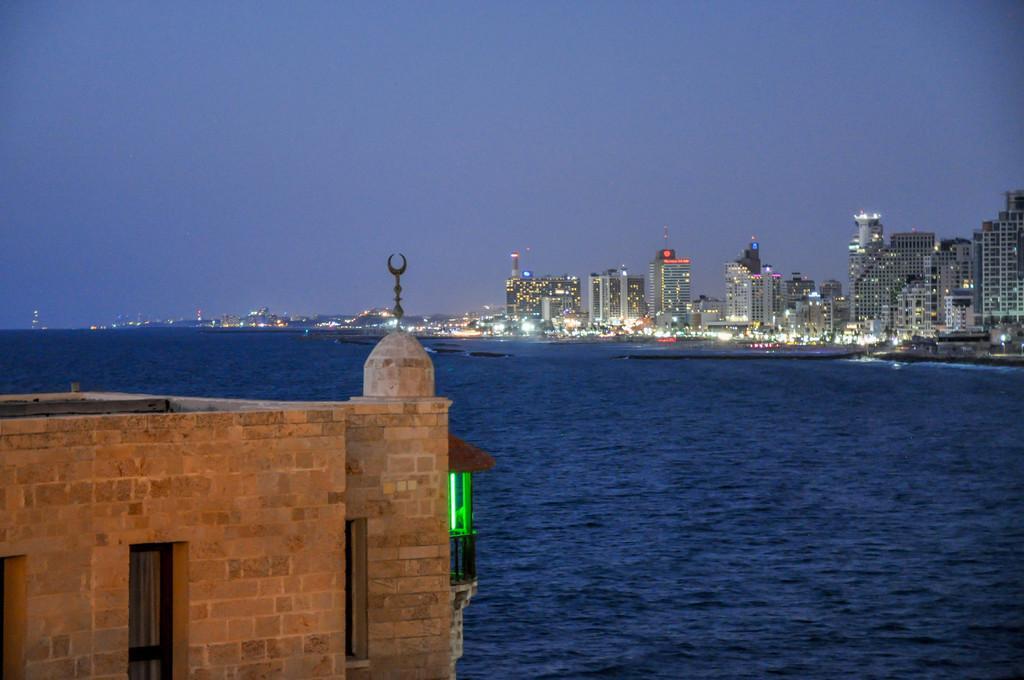Describe this image in one or two sentences. In this image there are buildings and lights. In the center we can see water. In the background there is sky. 